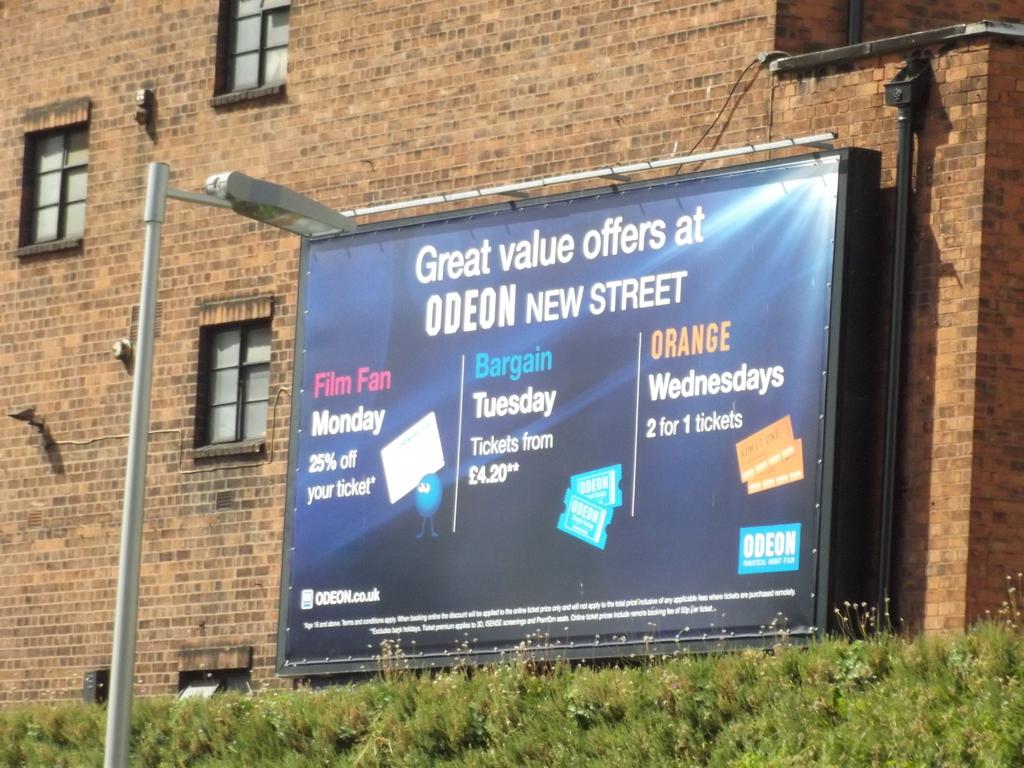What percentage do you get off on monday?
Make the answer very short. 25%. What colored word can be seen on the billboard?
Your response must be concise. Orange. 